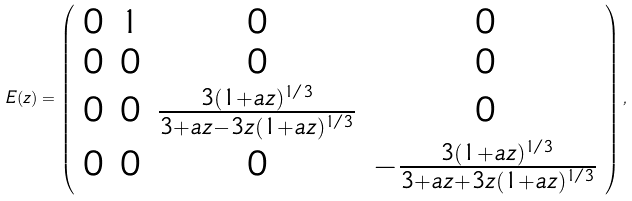Convert formula to latex. <formula><loc_0><loc_0><loc_500><loc_500>E ( z ) = \left ( \begin{array} { c c c c } 0 & 1 & 0 & 0 \\ 0 & 0 & 0 & 0 \\ 0 & 0 & \frac { 3 ( 1 + a z ) ^ { 1 / 3 } } { 3 + a z - 3 z ( 1 + a z ) ^ { 1 / 3 } } & 0 \\ 0 & 0 & 0 & - \frac { 3 ( 1 + a z ) ^ { 1 / 3 } } { 3 + a z + 3 z ( 1 + a z ) ^ { 1 / 3 } } \end{array} \right ) ,</formula> 